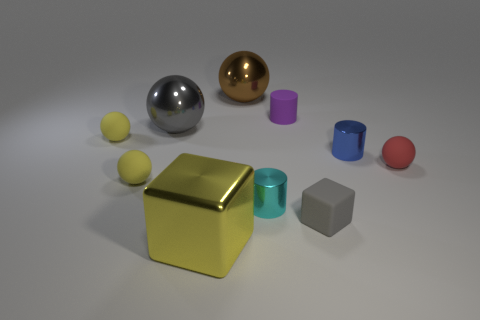There is a large thing that is the same color as the tiny matte cube; what is it made of? The large object sharing the color with the tiny matte cube appears to be a cube itself and, based on the visual cues such as its reflective surface, it is likely made of a metallic material, possibly aluminum or steel. 